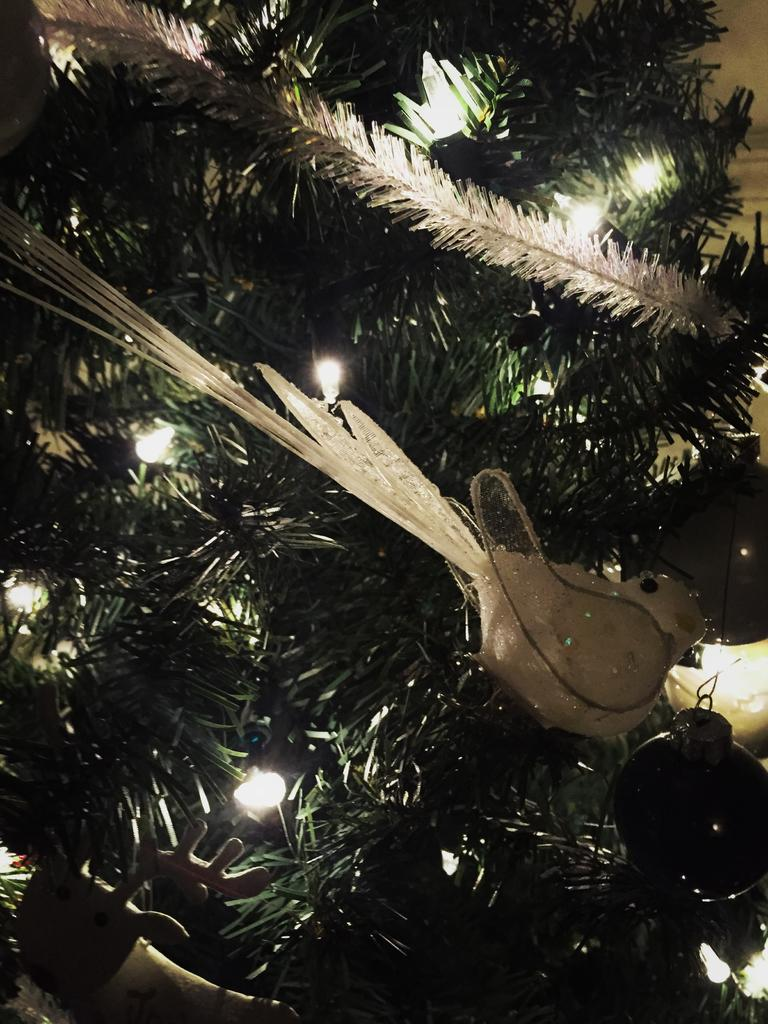What is present in the image? There is a plant in the image. What additional feature can be observed on the plant? There are lights decorated on the plant. What type of society is depicted in the image? There is no society depicted in the image; it features a plant with lights. What design principles were used to create the lights on the plant? The image does not provide information about the design principles used for the lights on the plant. 